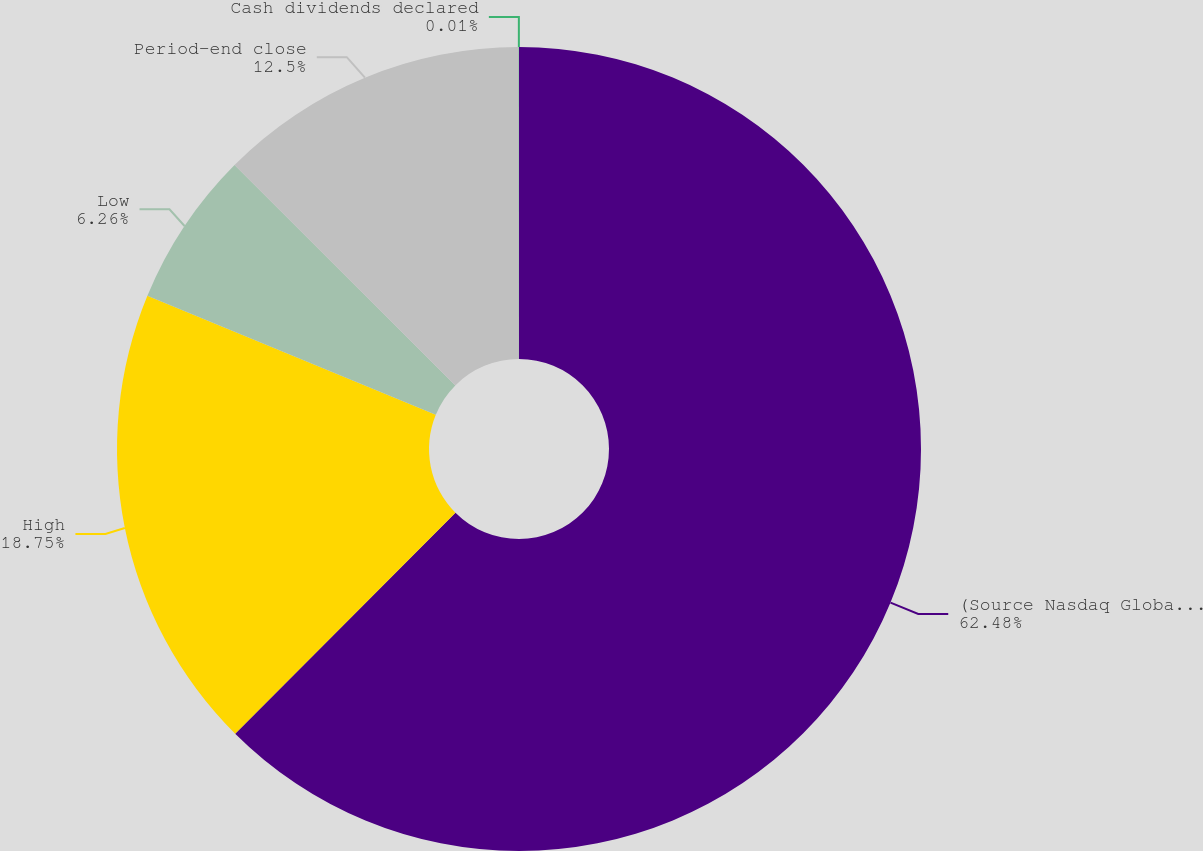<chart> <loc_0><loc_0><loc_500><loc_500><pie_chart><fcel>(Source Nasdaq Global Select<fcel>High<fcel>Low<fcel>Period-end close<fcel>Cash dividends declared<nl><fcel>62.47%<fcel>18.75%<fcel>6.26%<fcel>12.5%<fcel>0.01%<nl></chart> 